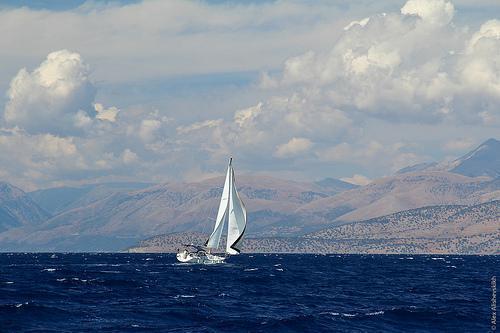How many boats?
Give a very brief answer. 1. 